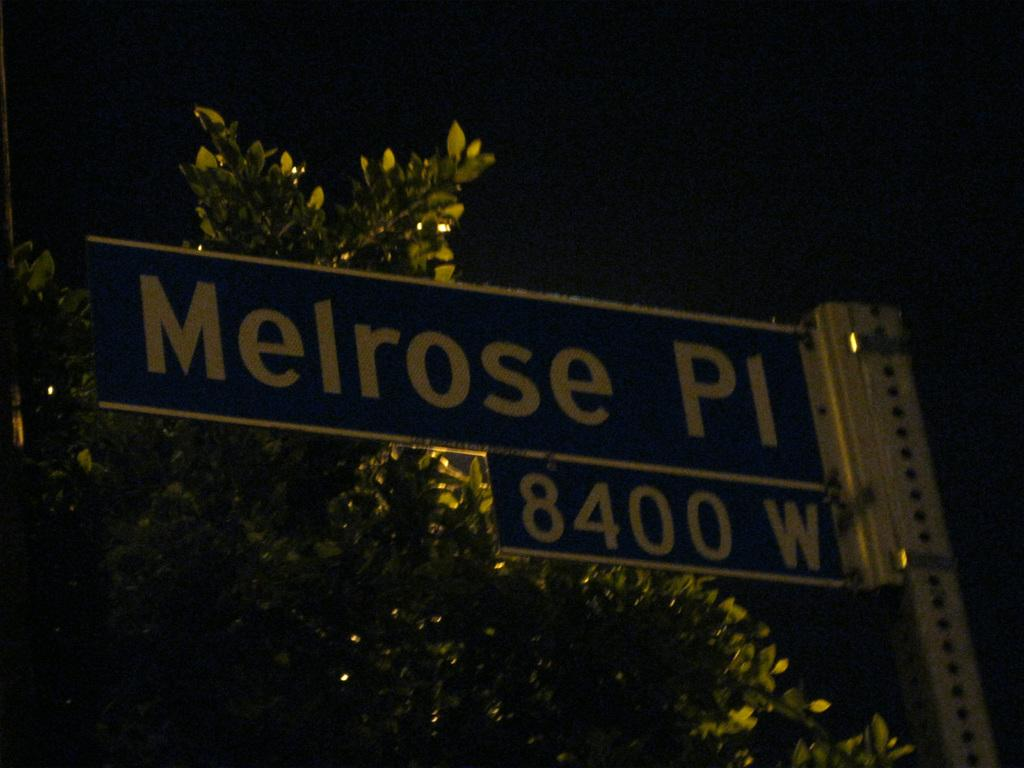What is the main object in the image? There is a name board in the image. What other objects or elements can be seen in the image? There is a tree and the sky visible in the image. What color is the goose that is sitting on the name board in the image? There is no goose present in the image. What type of material is the name board made of in the image? The provided facts do not mention the material of the name board, so we cannot answer that question. 